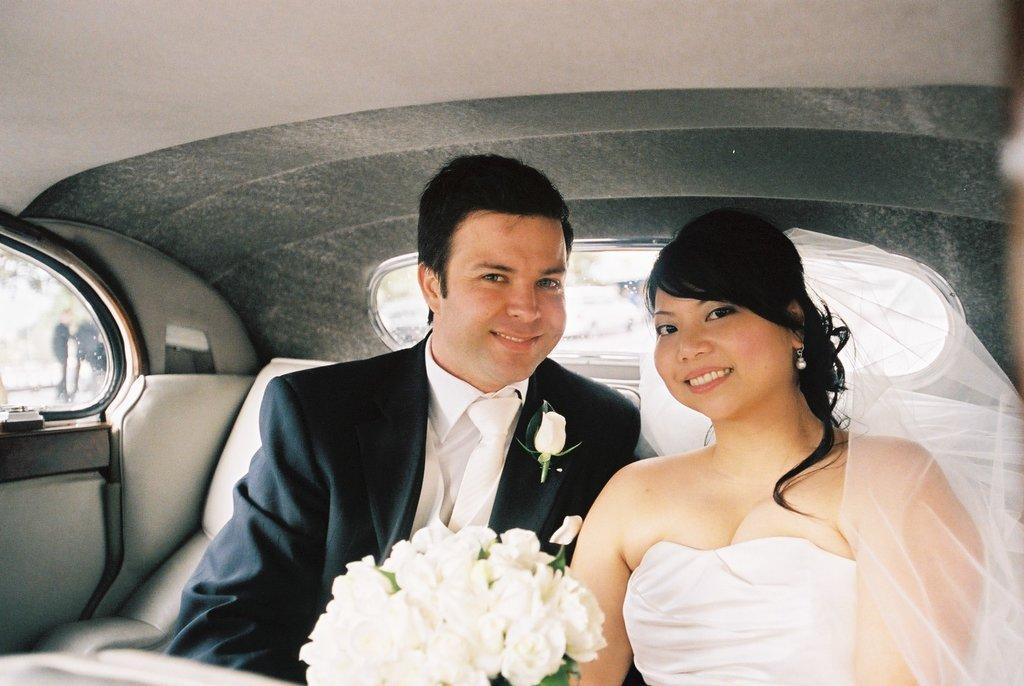Please provide a concise description of this image. in this image i can see two people sitting in the car. they are holding a white flower bouquet. the woman at the right is wearing white dress and smiling. the man at the left is wearing black suit with white tie and white shirt. 